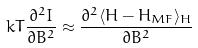<formula> <loc_0><loc_0><loc_500><loc_500>k T \frac { \partial ^ { 2 } I } { \partial B ^ { 2 } } \approx \frac { \partial ^ { 2 } \langle H - H _ { M F } \rangle _ { H } } { \partial B ^ { 2 } }</formula> 